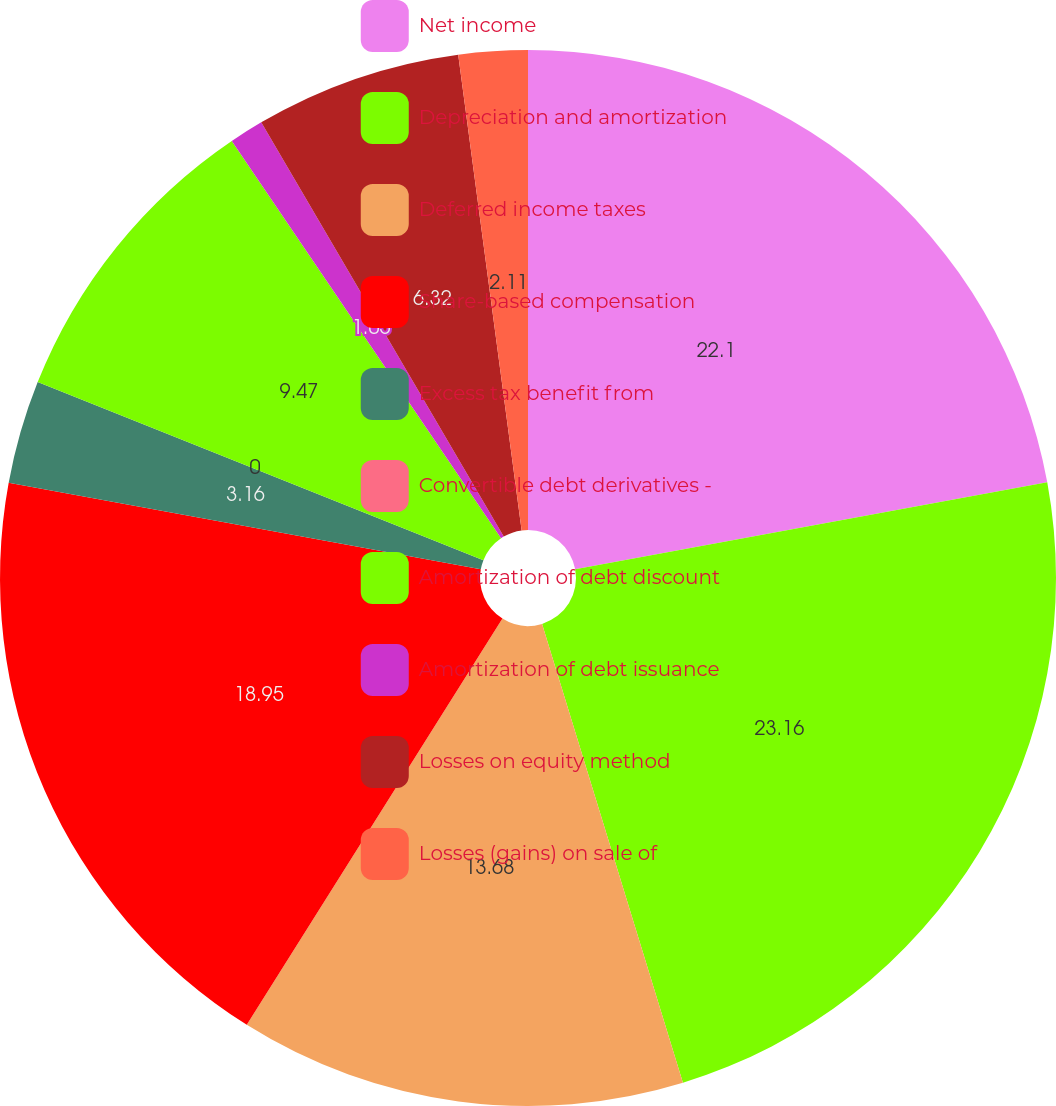<chart> <loc_0><loc_0><loc_500><loc_500><pie_chart><fcel>Net income<fcel>Depreciation and amortization<fcel>Deferred income taxes<fcel>Share-based compensation<fcel>Excess tax benefit from<fcel>Convertible debt derivatives -<fcel>Amortization of debt discount<fcel>Amortization of debt issuance<fcel>Losses on equity method<fcel>Losses (gains) on sale of<nl><fcel>22.1%<fcel>23.16%<fcel>13.68%<fcel>18.95%<fcel>3.16%<fcel>0.0%<fcel>9.47%<fcel>1.05%<fcel>6.32%<fcel>2.11%<nl></chart> 